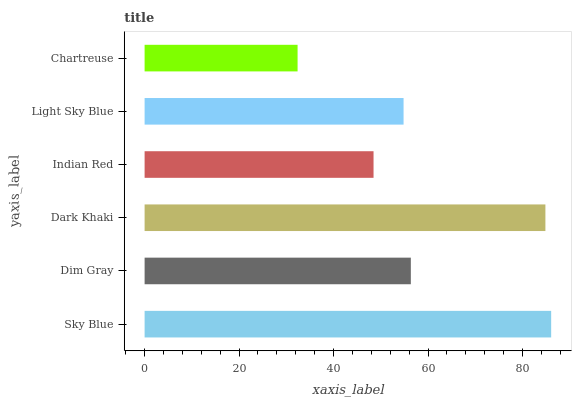Is Chartreuse the minimum?
Answer yes or no. Yes. Is Sky Blue the maximum?
Answer yes or no. Yes. Is Dim Gray the minimum?
Answer yes or no. No. Is Dim Gray the maximum?
Answer yes or no. No. Is Sky Blue greater than Dim Gray?
Answer yes or no. Yes. Is Dim Gray less than Sky Blue?
Answer yes or no. Yes. Is Dim Gray greater than Sky Blue?
Answer yes or no. No. Is Sky Blue less than Dim Gray?
Answer yes or no. No. Is Dim Gray the high median?
Answer yes or no. Yes. Is Light Sky Blue the low median?
Answer yes or no. Yes. Is Sky Blue the high median?
Answer yes or no. No. Is Dark Khaki the low median?
Answer yes or no. No. 